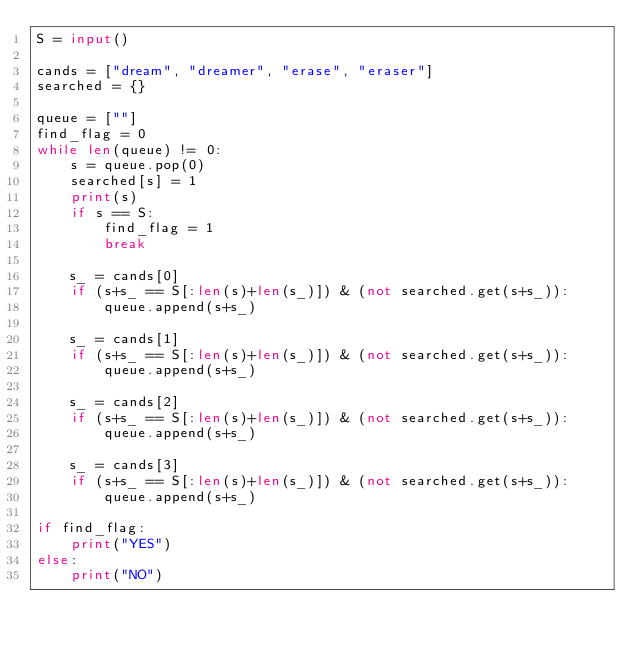Convert code to text. <code><loc_0><loc_0><loc_500><loc_500><_Python_>S = input()

cands = ["dream", "dreamer", "erase", "eraser"]
searched = {}

queue = [""]
find_flag = 0
while len(queue) != 0:
    s = queue.pop(0)
    searched[s] = 1
    print(s)
    if s == S:
        find_flag = 1
        break
        
    s_ = cands[0]
    if (s+s_ == S[:len(s)+len(s_)]) & (not searched.get(s+s_)):
        queue.append(s+s_)

    s_ = cands[1]
    if (s+s_ == S[:len(s)+len(s_)]) & (not searched.get(s+s_)):
        queue.append(s+s_)
        
    s_ = cands[2]
    if (s+s_ == S[:len(s)+len(s_)]) & (not searched.get(s+s_)):
        queue.append(s+s_)
        
    s_ = cands[3]
    if (s+s_ == S[:len(s)+len(s_)]) & (not searched.get(s+s_)):
        queue.append(s+s_)

if find_flag:
    print("YES")
else:
    print("NO")</code> 